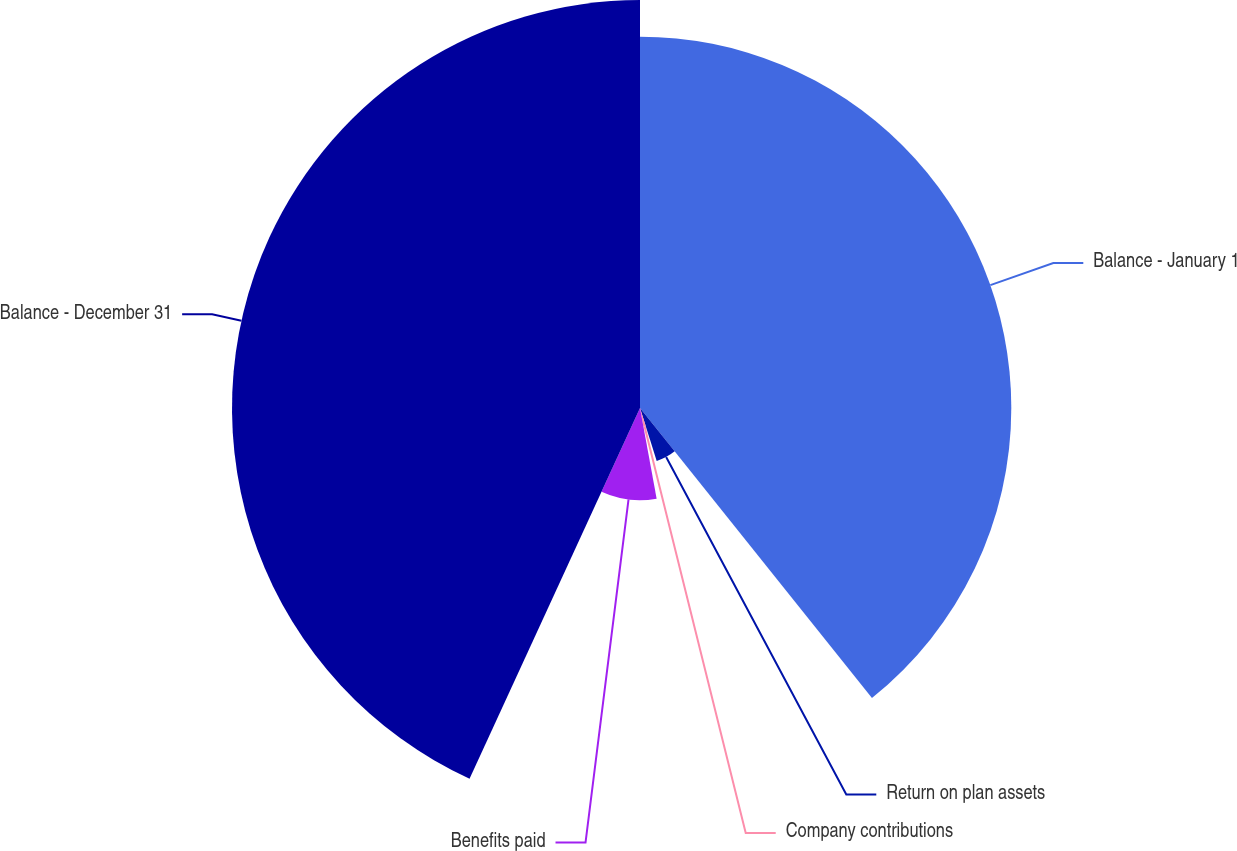Convert chart. <chart><loc_0><loc_0><loc_500><loc_500><pie_chart><fcel>Balance - January 1<fcel>Return on plan assets<fcel>Company contributions<fcel>Benefits paid<fcel>Balance - December 31<nl><fcel>39.26%<fcel>5.87%<fcel>1.98%<fcel>9.75%<fcel>43.14%<nl></chart> 